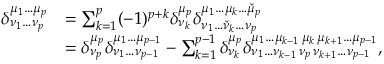<formula> <loc_0><loc_0><loc_500><loc_500>{ \begin{array} { r l } { \delta _ { \nu _ { 1 } \dots \nu _ { p } } ^ { \mu _ { 1 } \dots \mu _ { p } } } & { = \sum _ { k = 1 } ^ { p } ( - 1 ) ^ { p + k } \delta _ { \nu _ { k } } ^ { \mu _ { p } } \delta _ { \nu _ { 1 } \dots { \check { \nu } } _ { k } \dots \nu _ { p } } ^ { \mu _ { 1 } \dots \mu _ { k } \dots { \check { \mu } } _ { p } } } \\ & { = \delta _ { \nu _ { p } } ^ { \mu _ { p } } \delta _ { \nu _ { 1 } \dots \nu _ { p - 1 } } ^ { \mu _ { 1 } \dots \mu _ { p - 1 } } - \sum _ { k = 1 } ^ { p - 1 } \delta _ { \nu _ { k } } ^ { \mu _ { p } } \delta _ { \nu _ { 1 } \dots \nu _ { k - 1 } \, \nu _ { p } \, \nu _ { k + 1 } \dots \nu _ { p - 1 } } ^ { \mu _ { 1 } \dots \mu _ { k - 1 } \, \mu _ { k } \, \mu _ { k + 1 } \dots \mu _ { p - 1 } } , } \end{array} }</formula> 